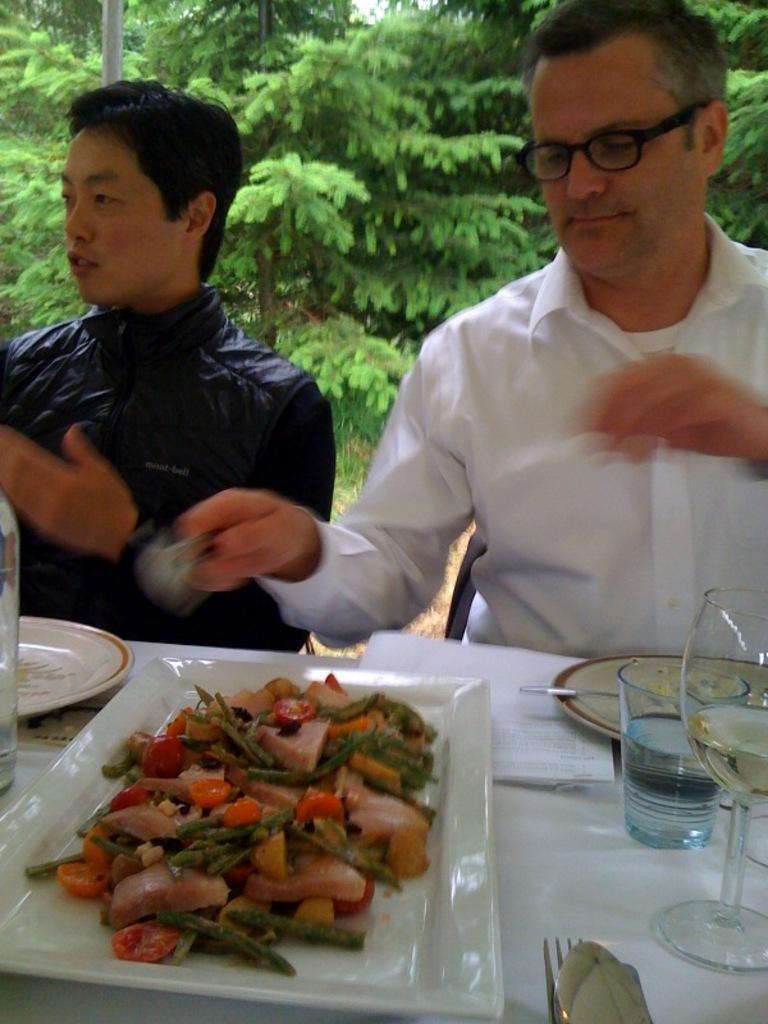In one or two sentences, can you explain what this image depicts? In this picture we can see a man wearing white shirt and sitting on a chair. Beside there is a boy wearing black jacket and sitting. In the front there is a food plate and glass on the dining table. In the background we can see some trees. 